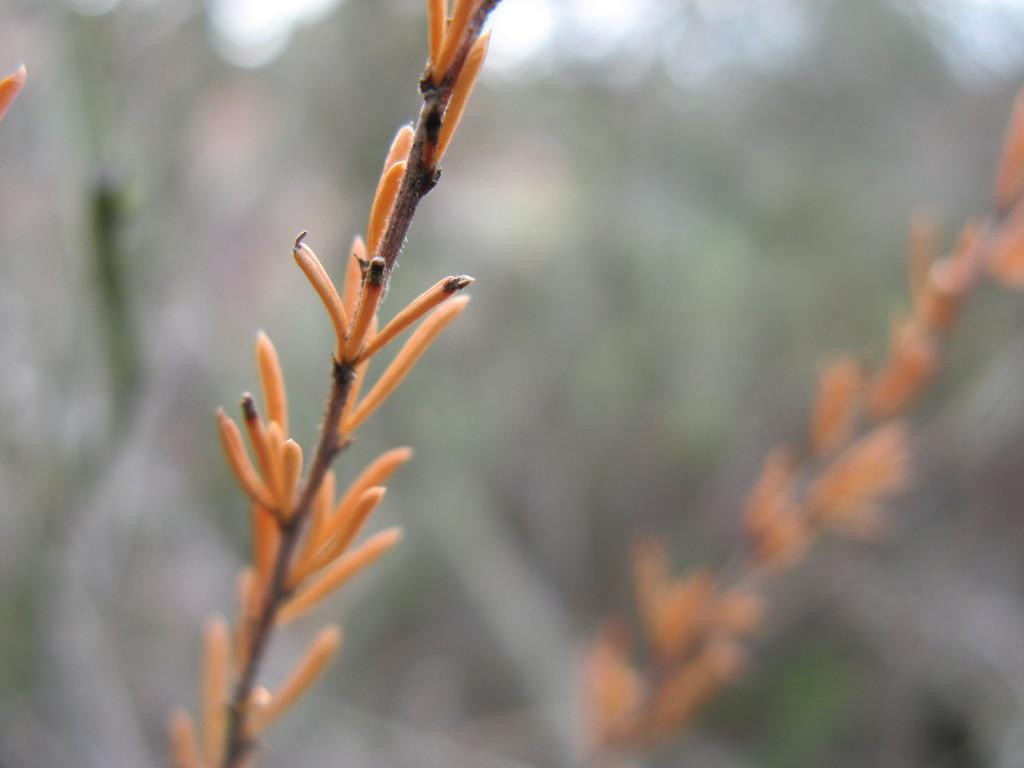What type of living organisms can be seen in the image? There are flowers in the image. What colors are the flowers? The flowers are orange and black in color. Are the flowers part of a larger plant? Yes, the flowers are associated with plants. How would you describe the background of the image? The background of the image is blurry. What type of coal is being used to fuel the boot in the image? There is no coal or boot present in the image. 